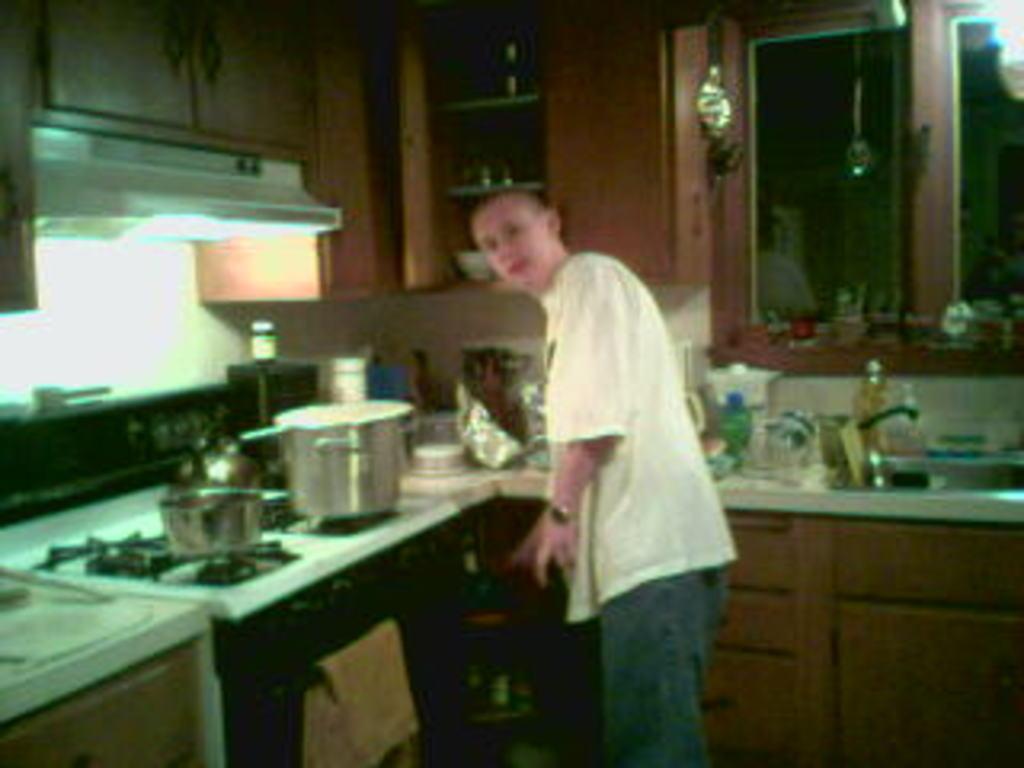In one or two sentences, can you explain what this image depicts? In this image there is a man standing on the floor in the kitchen. In front of him there is a stove on which there are vessels. On the right side top there is a cupboard. There is a kitchen platform beside him on which there are bottles,cups,bowls and some vessels on it. Above the stove there is a chimney. At the top there are cupboards in which there are metal vessels. On the left side there is a cloth which is hanged on the pole. 